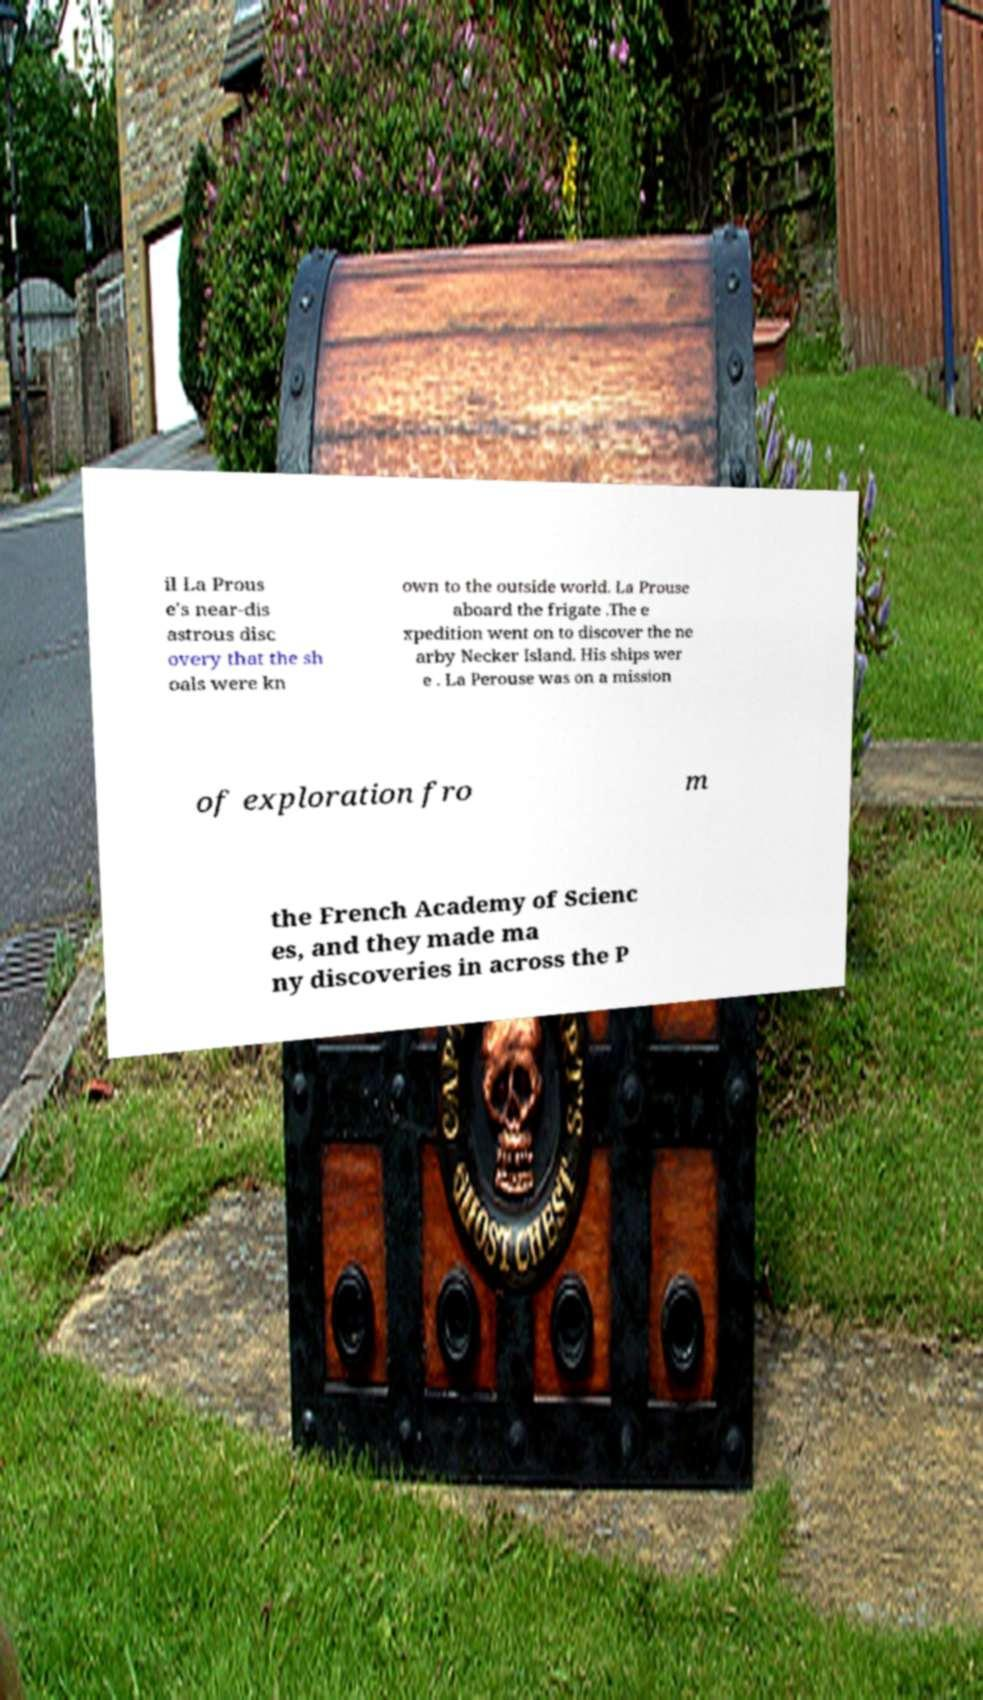Can you accurately transcribe the text from the provided image for me? il La Prous e's near-dis astrous disc overy that the sh oals were kn own to the outside world. La Prouse aboard the frigate .The e xpedition went on to discover the ne arby Necker Island. His ships wer e . La Perouse was on a mission of exploration fro m the French Academy of Scienc es, and they made ma ny discoveries in across the P 